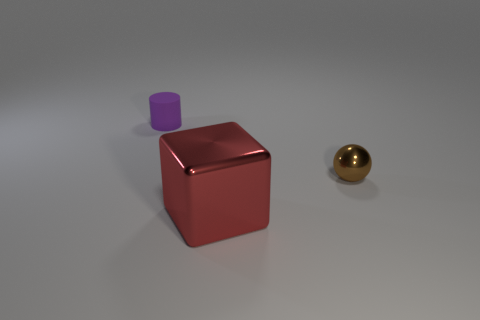Is there anything else that has the same material as the tiny purple thing?
Your answer should be very brief. No. Are the object in front of the ball and the small sphere made of the same material?
Provide a short and direct response. Yes. There is a thing that is in front of the sphere; does it have the same color as the rubber thing?
Your response must be concise. No. Are there any small brown balls in front of the large red cube?
Provide a succinct answer. No. What is the color of the object that is both behind the shiny block and on the left side of the brown metal thing?
Offer a terse response. Purple. There is a thing behind the tiny object that is on the right side of the red shiny block; how big is it?
Provide a succinct answer. Small. What number of cubes are big red things or small things?
Offer a terse response. 1. The rubber thing that is the same size as the sphere is what color?
Make the answer very short. Purple. There is a object that is to the left of the thing in front of the brown thing; what shape is it?
Your answer should be very brief. Cylinder. Is the size of the metallic object in front of the brown object the same as the purple matte cylinder?
Give a very brief answer. No. 